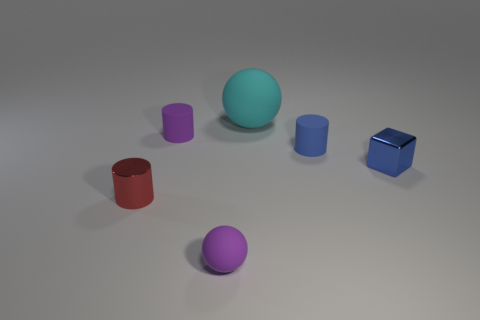Which objects in the image have the same color tone? The two purplish objects, one cylinder and one sphere, share a similar color tone, although the sphere is a slight shade darker. Do any objects share a similar size? Yes, the red cylinder and the purple sphere are roughly similar in size, although they are different shapes. 